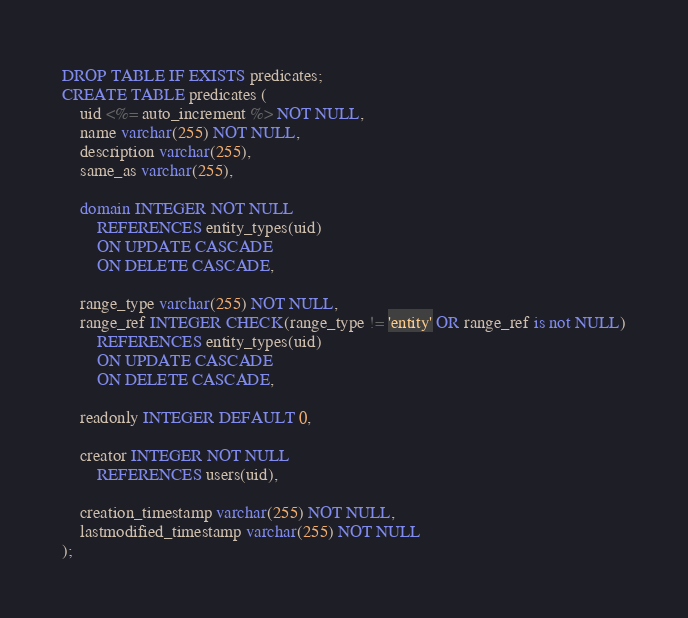<code> <loc_0><loc_0><loc_500><loc_500><_SQL_>DROP TABLE IF EXISTS predicates;
CREATE TABLE predicates (
    uid <%= auto_increment %> NOT NULL,
    name varchar(255) NOT NULL,
    description varchar(255),
    same_as varchar(255),

    domain INTEGER NOT NULL 
        REFERENCES entity_types(uid)
        ON UPDATE CASCADE
        ON DELETE CASCADE,

    range_type varchar(255) NOT NULL,
    range_ref INTEGER CHECK(range_type != 'entity' OR range_ref is not NULL)
        REFERENCES entity_types(uid)
        ON UPDATE CASCADE
        ON DELETE CASCADE,
        
    readonly INTEGER DEFAULT 0,

    creator INTEGER NOT NULL
        REFERENCES users(uid),

    creation_timestamp varchar(255) NOT NULL,
    lastmodified_timestamp varchar(255) NOT NULL
);</code> 